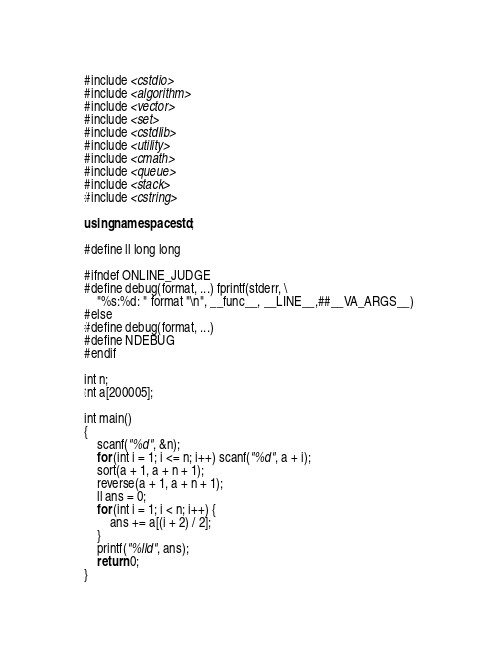Convert code to text. <code><loc_0><loc_0><loc_500><loc_500><_C++_>#include <cstdio>
#include <algorithm>
#include <vector>
#include <set>
#include <cstdlib>
#include <utility>
#include <cmath>
#include <queue>
#include <stack>
#include <cstring>

using namespace std;

#define ll long long

#ifndef ONLINE_JUDGE
#define debug(format, ...) fprintf(stderr, \
    "%s:%d: " format "\n", __func__, __LINE__,##__VA_ARGS__)
#else
#define debug(format, ...)
#define NDEBUG
#endif

int n;
int a[200005];

int main()
{
    scanf("%d", &n);
    for (int i = 1; i <= n; i++) scanf("%d", a + i);
    sort(a + 1, a + n + 1);
    reverse(a + 1, a + n + 1);
    ll ans = 0;
    for (int i = 1; i < n; i++) {
        ans += a[(i + 2) / 2];
    }
    printf("%lld", ans);
    return 0;
}
</code> 